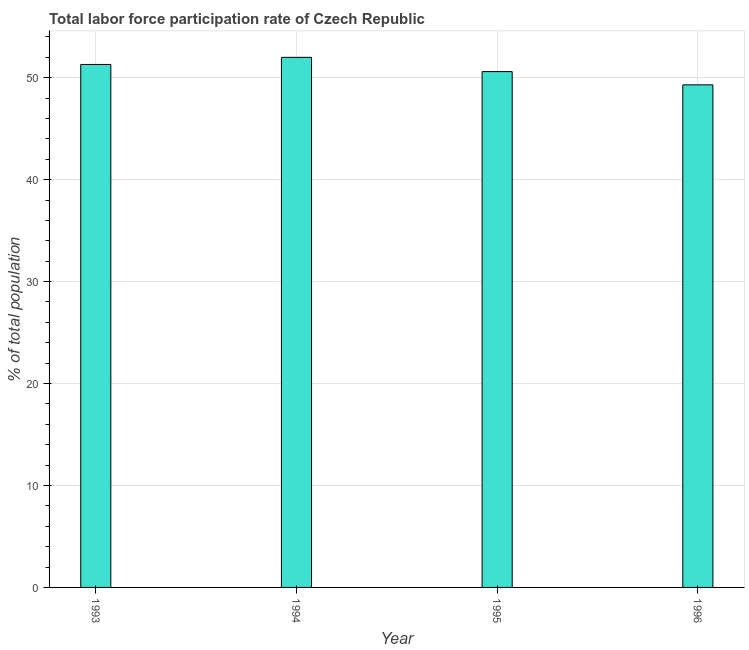Does the graph contain grids?
Offer a very short reply. Yes. What is the title of the graph?
Give a very brief answer. Total labor force participation rate of Czech Republic. What is the label or title of the X-axis?
Give a very brief answer. Year. What is the label or title of the Y-axis?
Offer a terse response. % of total population. What is the total labor force participation rate in 1994?
Offer a very short reply. 52. Across all years, what is the maximum total labor force participation rate?
Offer a terse response. 52. Across all years, what is the minimum total labor force participation rate?
Ensure brevity in your answer.  49.3. In which year was the total labor force participation rate maximum?
Provide a succinct answer. 1994. In which year was the total labor force participation rate minimum?
Provide a succinct answer. 1996. What is the sum of the total labor force participation rate?
Keep it short and to the point. 203.2. What is the average total labor force participation rate per year?
Offer a very short reply. 50.8. What is the median total labor force participation rate?
Offer a terse response. 50.95. In how many years, is the total labor force participation rate greater than 22 %?
Your response must be concise. 4. Is the total labor force participation rate in 1994 less than that in 1996?
Your answer should be very brief. No. What is the difference between the highest and the second highest total labor force participation rate?
Provide a succinct answer. 0.7. What is the difference between the highest and the lowest total labor force participation rate?
Your answer should be compact. 2.7. How many years are there in the graph?
Provide a succinct answer. 4. Are the values on the major ticks of Y-axis written in scientific E-notation?
Give a very brief answer. No. What is the % of total population in 1993?
Make the answer very short. 51.3. What is the % of total population in 1994?
Offer a terse response. 52. What is the % of total population in 1995?
Offer a very short reply. 50.6. What is the % of total population of 1996?
Your answer should be compact. 49.3. What is the difference between the % of total population in 1994 and 1996?
Keep it short and to the point. 2.7. What is the ratio of the % of total population in 1993 to that in 1994?
Make the answer very short. 0.99. What is the ratio of the % of total population in 1993 to that in 1995?
Provide a succinct answer. 1.01. What is the ratio of the % of total population in 1993 to that in 1996?
Make the answer very short. 1.04. What is the ratio of the % of total population in 1994 to that in 1995?
Offer a terse response. 1.03. What is the ratio of the % of total population in 1994 to that in 1996?
Offer a very short reply. 1.05. 